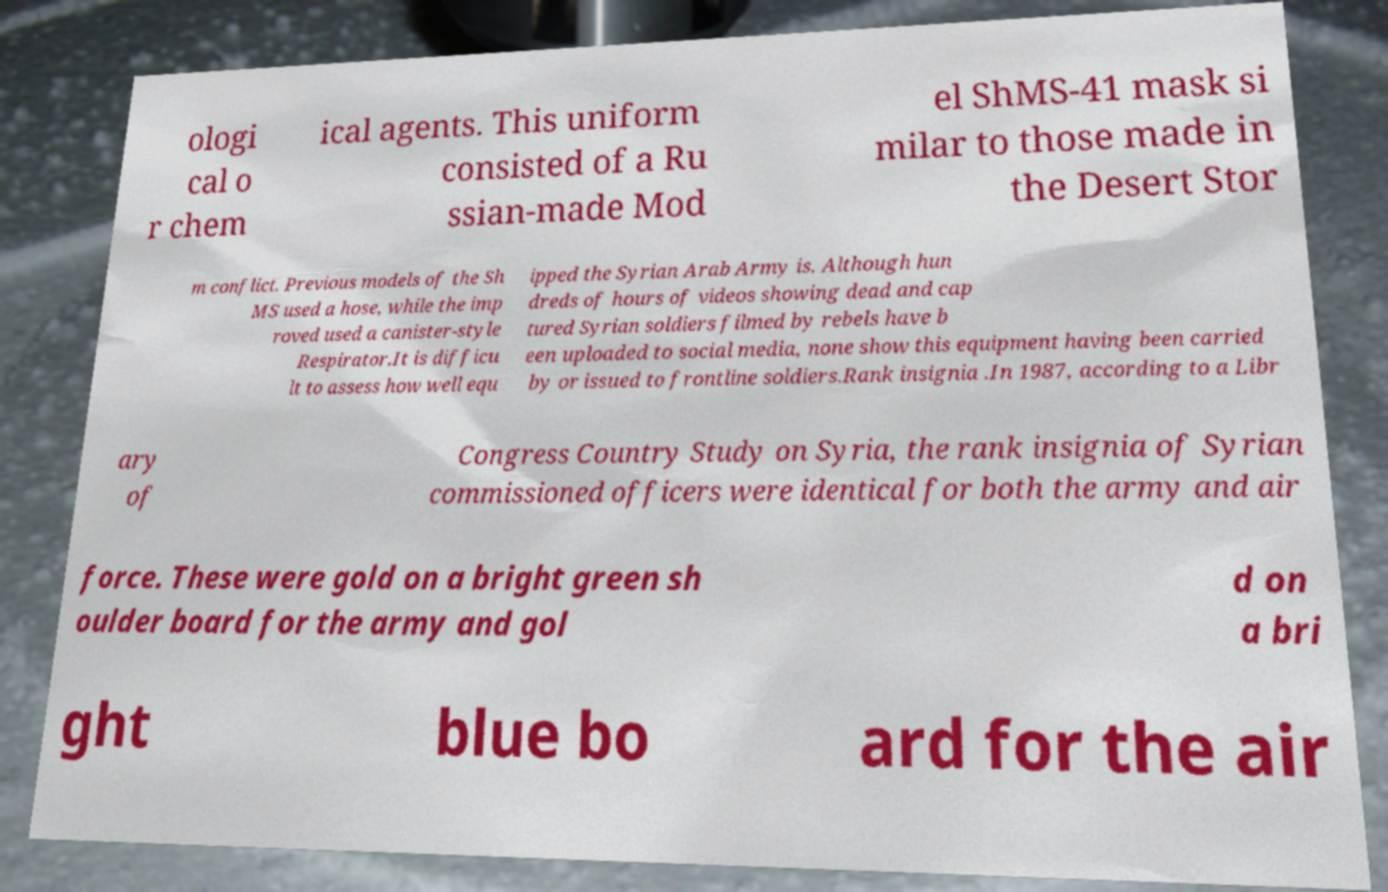Could you assist in decoding the text presented in this image and type it out clearly? ologi cal o r chem ical agents. This uniform consisted of a Ru ssian-made Mod el ShMS-41 mask si milar to those made in the Desert Stor m conflict. Previous models of the Sh MS used a hose, while the imp roved used a canister-style Respirator.It is difficu lt to assess how well equ ipped the Syrian Arab Army is. Although hun dreds of hours of videos showing dead and cap tured Syrian soldiers filmed by rebels have b een uploaded to social media, none show this equipment having been carried by or issued to frontline soldiers.Rank insignia .In 1987, according to a Libr ary of Congress Country Study on Syria, the rank insignia of Syrian commissioned officers were identical for both the army and air force. These were gold on a bright green sh oulder board for the army and gol d on a bri ght blue bo ard for the air 